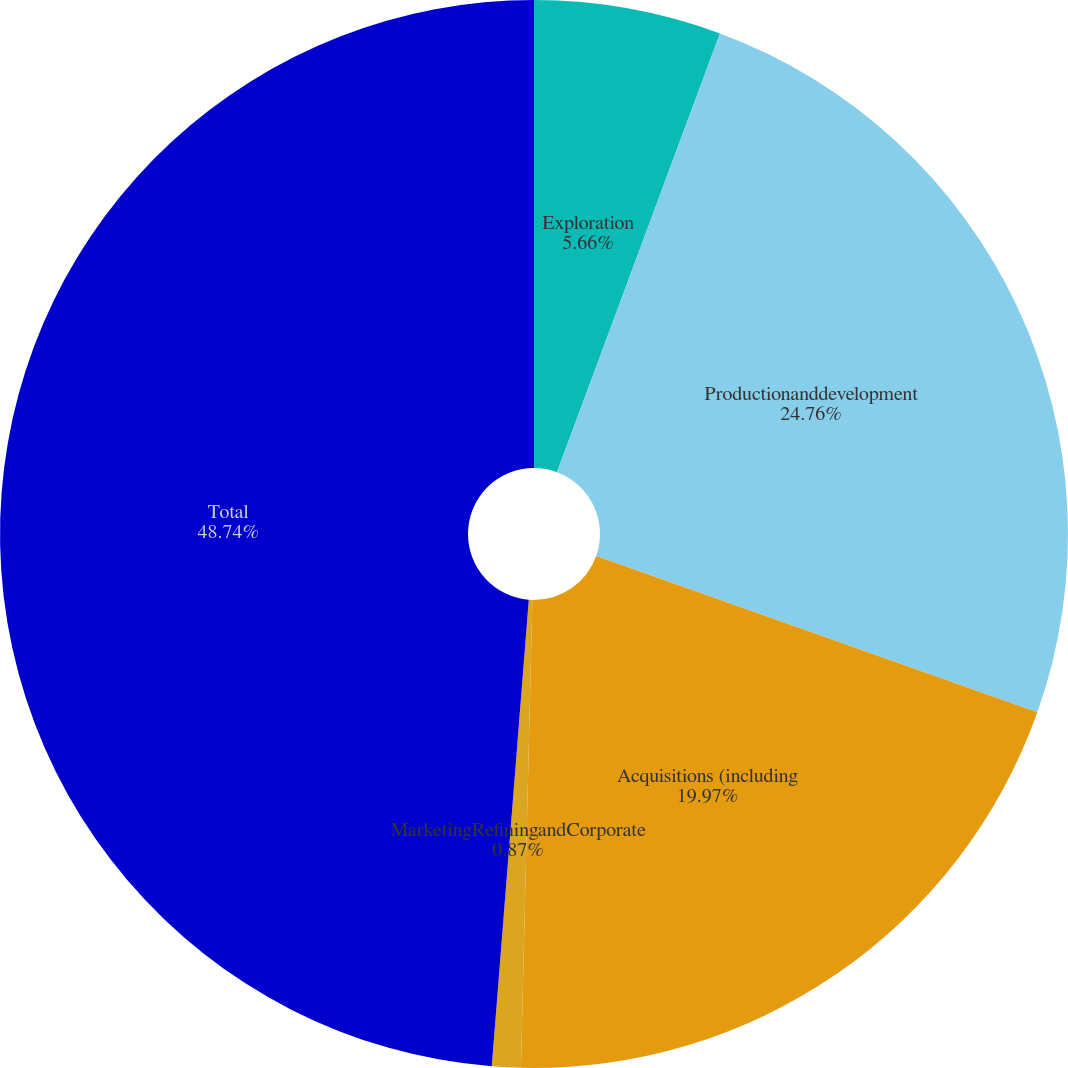Convert chart to OTSL. <chart><loc_0><loc_0><loc_500><loc_500><pie_chart><fcel>Exploration<fcel>Productionanddevelopment<fcel>Acquisitions (including<fcel>MarketingRefiningandCorporate<fcel>Total<nl><fcel>5.66%<fcel>24.76%<fcel>19.97%<fcel>0.87%<fcel>48.74%<nl></chart> 